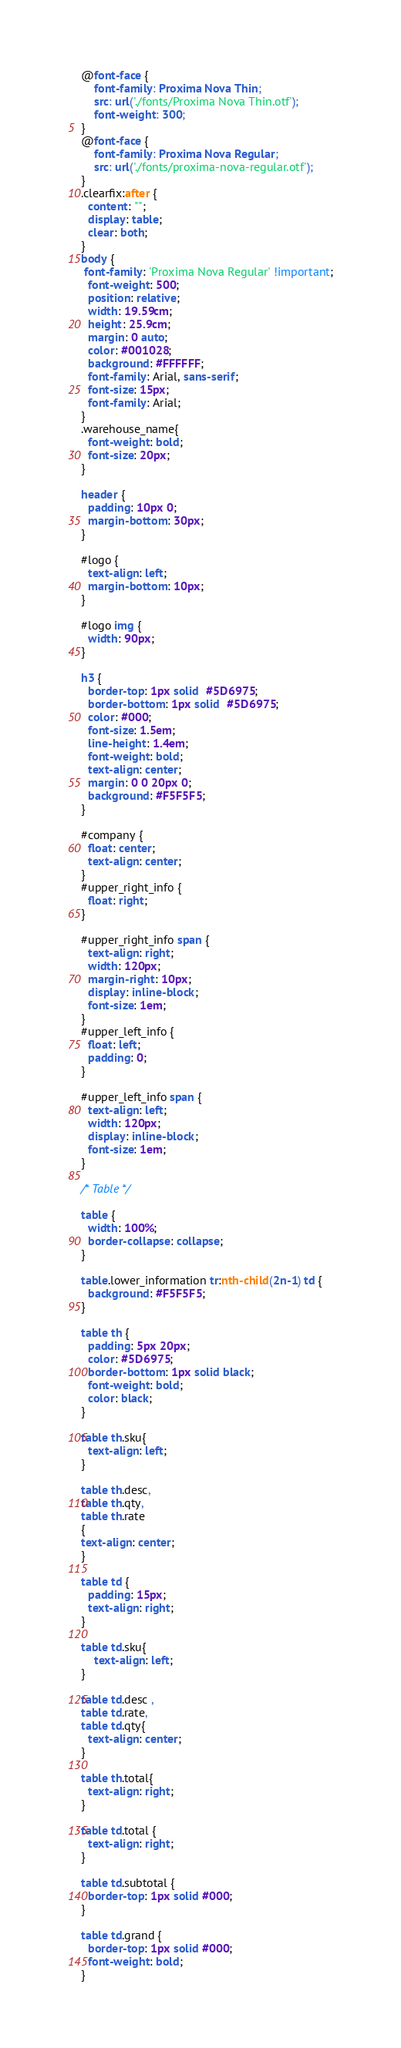Convert code to text. <code><loc_0><loc_0><loc_500><loc_500><_CSS_>@font-face {
    font-family: Proxima Nova Thin;
    src: url('./fonts/Proxima Nova Thin.otf');
    font-weight: 300;
}
@font-face {
    font-family: Proxima Nova Regular;
    src: url('./fonts/proxima-nova-regular.otf');
}
.clearfix:after {
  content: "";
  display: table;
  clear: both;
}
body {
 font-family: 'Proxima Nova Regular' !important;
  font-weight: 500;
  position: relative;
  width: 19.59cm;  
  height: 25.9cm; 
  margin: 0 auto; 
  color: #001028;
  background: #FFFFFF; 
  font-family: Arial, sans-serif; 
  font-size: 15px; 
  font-family: Arial;
}
.warehouse_name{
  font-weight: bold;
  font-size: 20px;
}

header {
  padding: 10px 0;
  margin-bottom: 30px;
}

#logo {
  text-align: left;
  margin-bottom: 10px;
}

#logo img {
  width: 90px;
}

h3 {
  border-top: 1px solid  #5D6975;
  border-bottom: 1px solid  #5D6975;
  color: #000;
  font-size: 1.5em;
  line-height: 1.4em;
  font-weight: bold;
  text-align: center;
  margin: 0 0 20px 0;
  background: #F5F5F5;
}

#company {
  float: center;
  text-align: center;
}
#upper_right_info {
  float: right;
}

#upper_right_info span {
  text-align: right;
  width: 120px;
  margin-right: 10px;
  display: inline-block;
  font-size: 1em;
}
#upper_left_info {
  float: left;
  padding: 0;
}

#upper_left_info span {
  text-align: left;
  width: 120px;
  display: inline-block;
  font-size: 1em;
}

/* Table */

table {
  width: 100%;
  border-collapse: collapse;
}

table.lower_information tr:nth-child(2n-1) td {
  background: #F5F5F5;
}

table th {
  padding: 5px 20px;
  color: #5D6975;
  border-bottom: 1px solid black;        
  font-weight: bold;
  color: black;
}

table th.sku{
  text-align: left;
}

table th.desc,
table th.qty,
table th.rate
{
text-align: center;
}

table td {
  padding: 15px;
  text-align: right;
}

table td.sku{
	text-align: left;
}

table td.desc , 
table td.rate,
table td.qty{
  text-align: center;
}

table th.total{
  text-align: right;
}

table td.total {
  text-align: right;
}

table td.subtotal {
  border-top: 1px solid #000;
}

table td.grand {
  border-top: 1px solid #000;
  font-weight: bold;
}</code> 